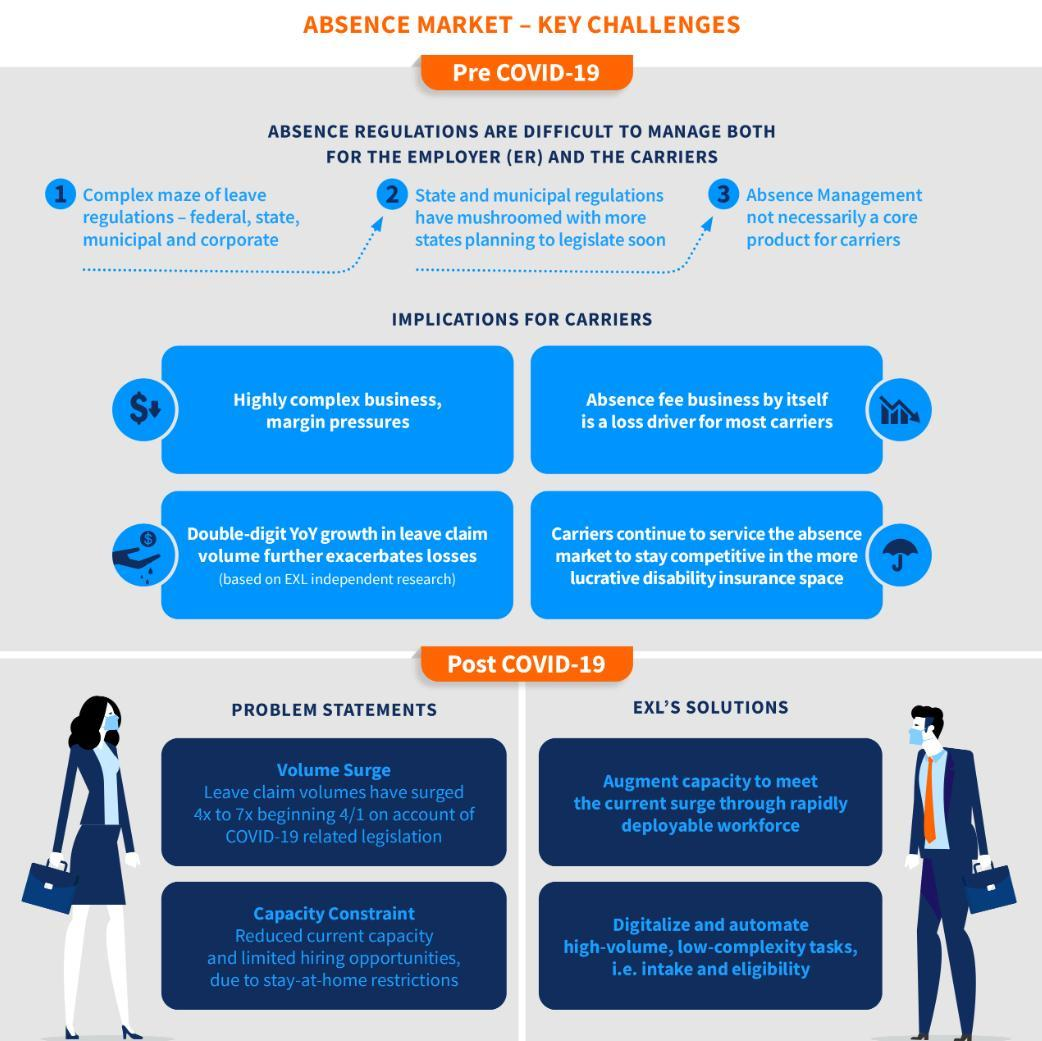What is the solution for capacity constraint problem due to stay-at-home restrictions?
Answer the question with a short phrase. Digitalize and automate high-volume, low-complexity tasks, i.e. intake and eligibility What is the reason for the current capacity constraint? stay-at-home restrictions What is EXL's solution for volume surge problem? Augment capacity to meet the current surge through rapidly deployable workforce What is the growth in leave claim volumes from the 1st of April? 7x Which type of works can be digitized and automated? high-volume, low-complexity tasks 